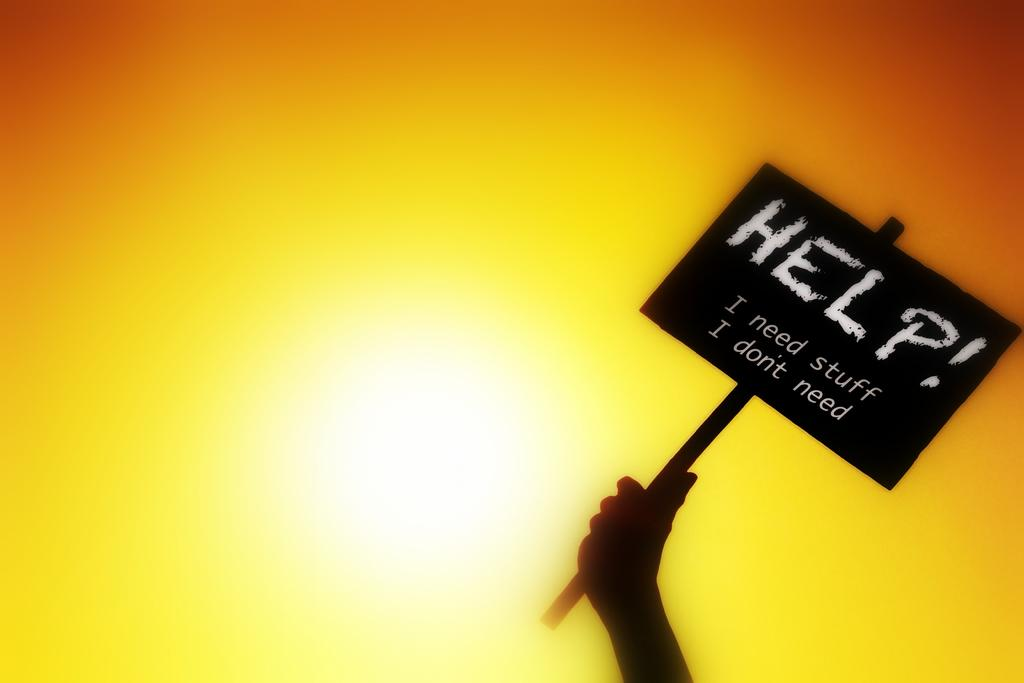Who or what is the main subject in the image? There is a person in the image. What is the person holding in the image? The person is holding a blackboard. What can be seen written on the blackboard? There is text written on the blackboard. Can you describe the colors present in the background of the image? The background of the image contains white, yellow, and orange colors. What type of guitar can be seen hanging on the wall in the image? There is no guitar present in the image; it only features a person holding a blackboard with text. How many bells are visible in the image in the image? There are no bells visible in the image. 